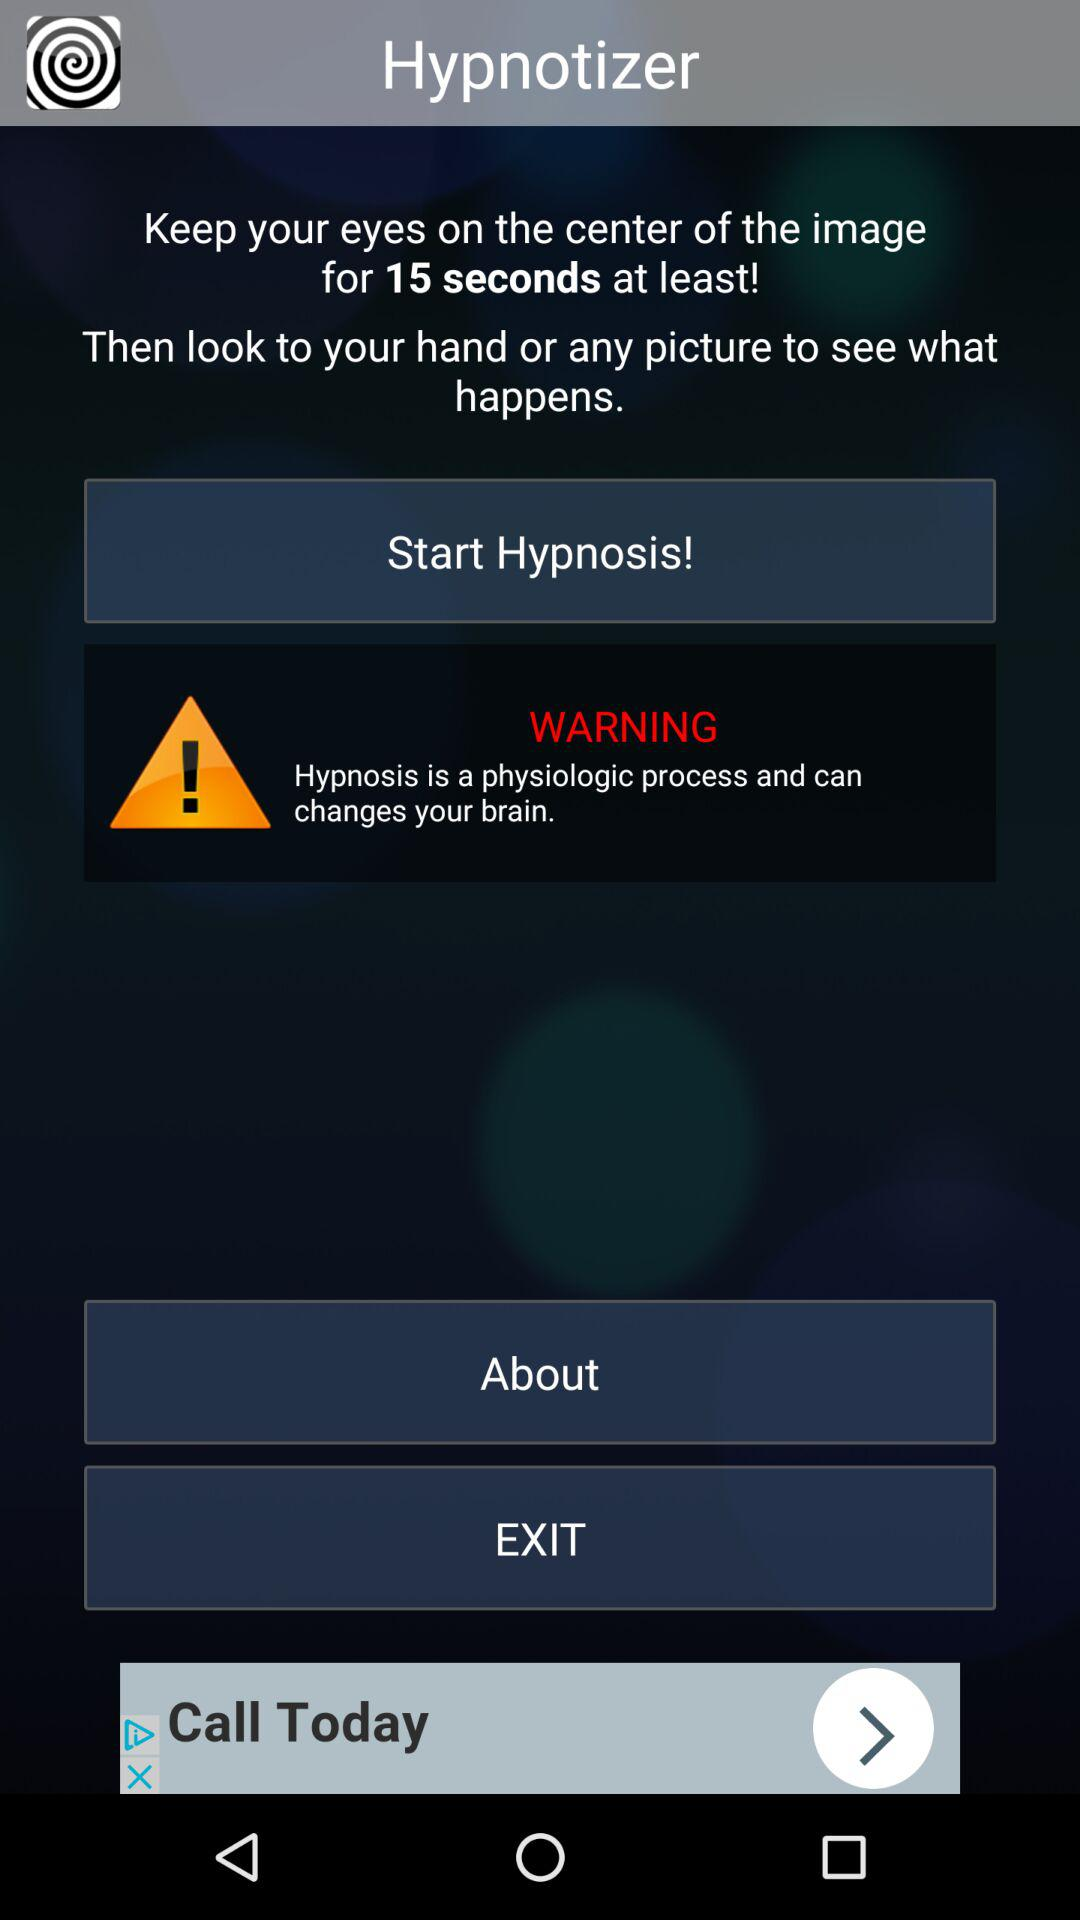What is the name of the application? The name of the application is "Hypnotizer". 